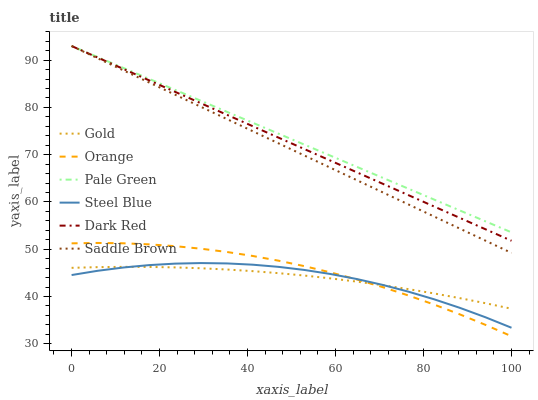Does Steel Blue have the minimum area under the curve?
Answer yes or no. Yes. Does Pale Green have the maximum area under the curve?
Answer yes or no. Yes. Does Dark Red have the minimum area under the curve?
Answer yes or no. No. Does Dark Red have the maximum area under the curve?
Answer yes or no. No. Is Saddle Brown the smoothest?
Answer yes or no. Yes. Is Steel Blue the roughest?
Answer yes or no. Yes. Is Dark Red the smoothest?
Answer yes or no. No. Is Dark Red the roughest?
Answer yes or no. No. Does Orange have the lowest value?
Answer yes or no. Yes. Does Dark Red have the lowest value?
Answer yes or no. No. Does Saddle Brown have the highest value?
Answer yes or no. Yes. Does Steel Blue have the highest value?
Answer yes or no. No. Is Orange less than Dark Red?
Answer yes or no. Yes. Is Pale Green greater than Steel Blue?
Answer yes or no. Yes. Does Orange intersect Gold?
Answer yes or no. Yes. Is Orange less than Gold?
Answer yes or no. No. Is Orange greater than Gold?
Answer yes or no. No. Does Orange intersect Dark Red?
Answer yes or no. No. 